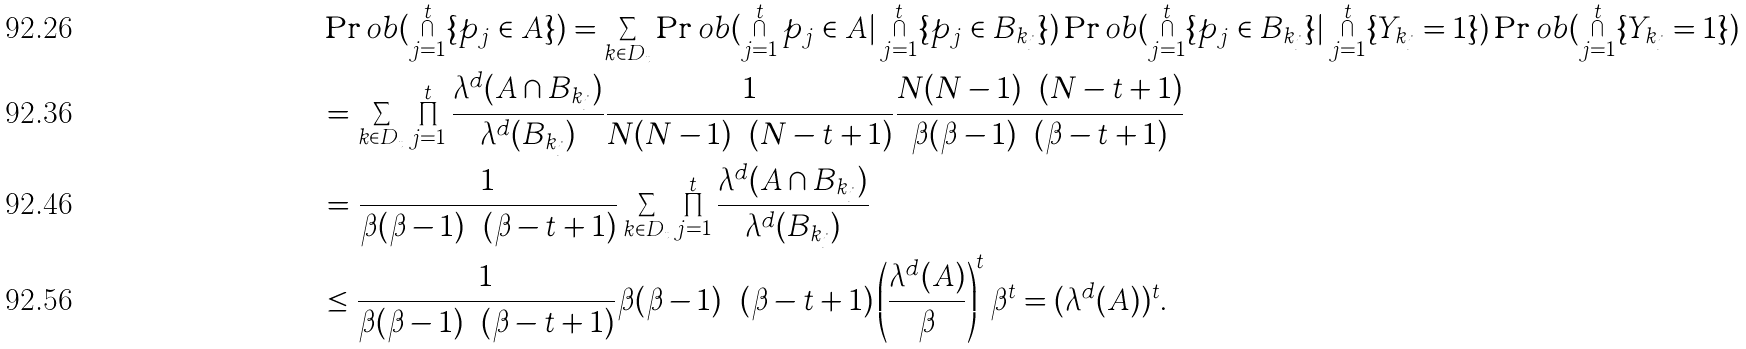<formula> <loc_0><loc_0><loc_500><loc_500>& \Pr o b ( \bigcap _ { j = 1 } ^ { t } \{ p _ { j } \in A \} ) = \sum _ { k \in D _ { t } } \Pr o b ( \bigcap _ { j = 1 } ^ { t } p _ { j } \in A | \bigcap _ { j = 1 } ^ { t } \{ p _ { j } \in B _ { k _ { j } } \} ) \Pr o b ( \bigcap _ { j = 1 } ^ { t } \{ p _ { j } \in B _ { k _ { j } } \} | \bigcap _ { j = 1 } ^ { t } \{ Y _ { k _ { j } } = 1 \} ) \Pr o b ( \bigcap _ { j = 1 } ^ { t } \{ Y _ { k _ { j } } = 1 \} ) \\ & = \sum _ { k \in D _ { t } } \prod _ { j = 1 } ^ { t } \frac { \lambda ^ { d } ( A \cap B _ { k _ { j } } ) } { \lambda ^ { d } ( B _ { k _ { j } } ) } \frac { 1 } { N ( N - 1 ) \cdots ( N - t + 1 ) } \frac { N ( N - 1 ) \cdots ( N - t + 1 ) } { \beta ( \beta - 1 ) \cdots ( \beta - t + 1 ) } \\ & = \frac { 1 } { \beta ( \beta - 1 ) \cdots ( \beta - t + 1 ) } \sum _ { k \in D _ { t } } \prod _ { j = 1 } ^ { t } \frac { \lambda ^ { d } ( A \cap B _ { k _ { j } } ) } { \lambda ^ { d } ( B _ { k _ { j } } ) } \\ & \leq \frac { 1 } { \beta ( \beta - 1 ) \cdots ( \beta - t + 1 ) } \beta ( \beta - 1 ) \cdots ( \beta - t + 1 ) \left ( \frac { \lambda ^ { d } ( A ) } { \beta } \right ) ^ { t } \beta ^ { t } = ( \lambda ^ { d } ( A ) ) ^ { t } .</formula> 